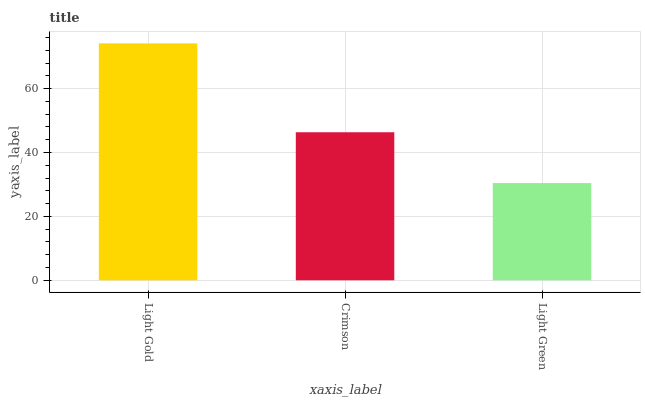Is Light Green the minimum?
Answer yes or no. Yes. Is Light Gold the maximum?
Answer yes or no. Yes. Is Crimson the minimum?
Answer yes or no. No. Is Crimson the maximum?
Answer yes or no. No. Is Light Gold greater than Crimson?
Answer yes or no. Yes. Is Crimson less than Light Gold?
Answer yes or no. Yes. Is Crimson greater than Light Gold?
Answer yes or no. No. Is Light Gold less than Crimson?
Answer yes or no. No. Is Crimson the high median?
Answer yes or no. Yes. Is Crimson the low median?
Answer yes or no. Yes. Is Light Gold the high median?
Answer yes or no. No. Is Light Green the low median?
Answer yes or no. No. 